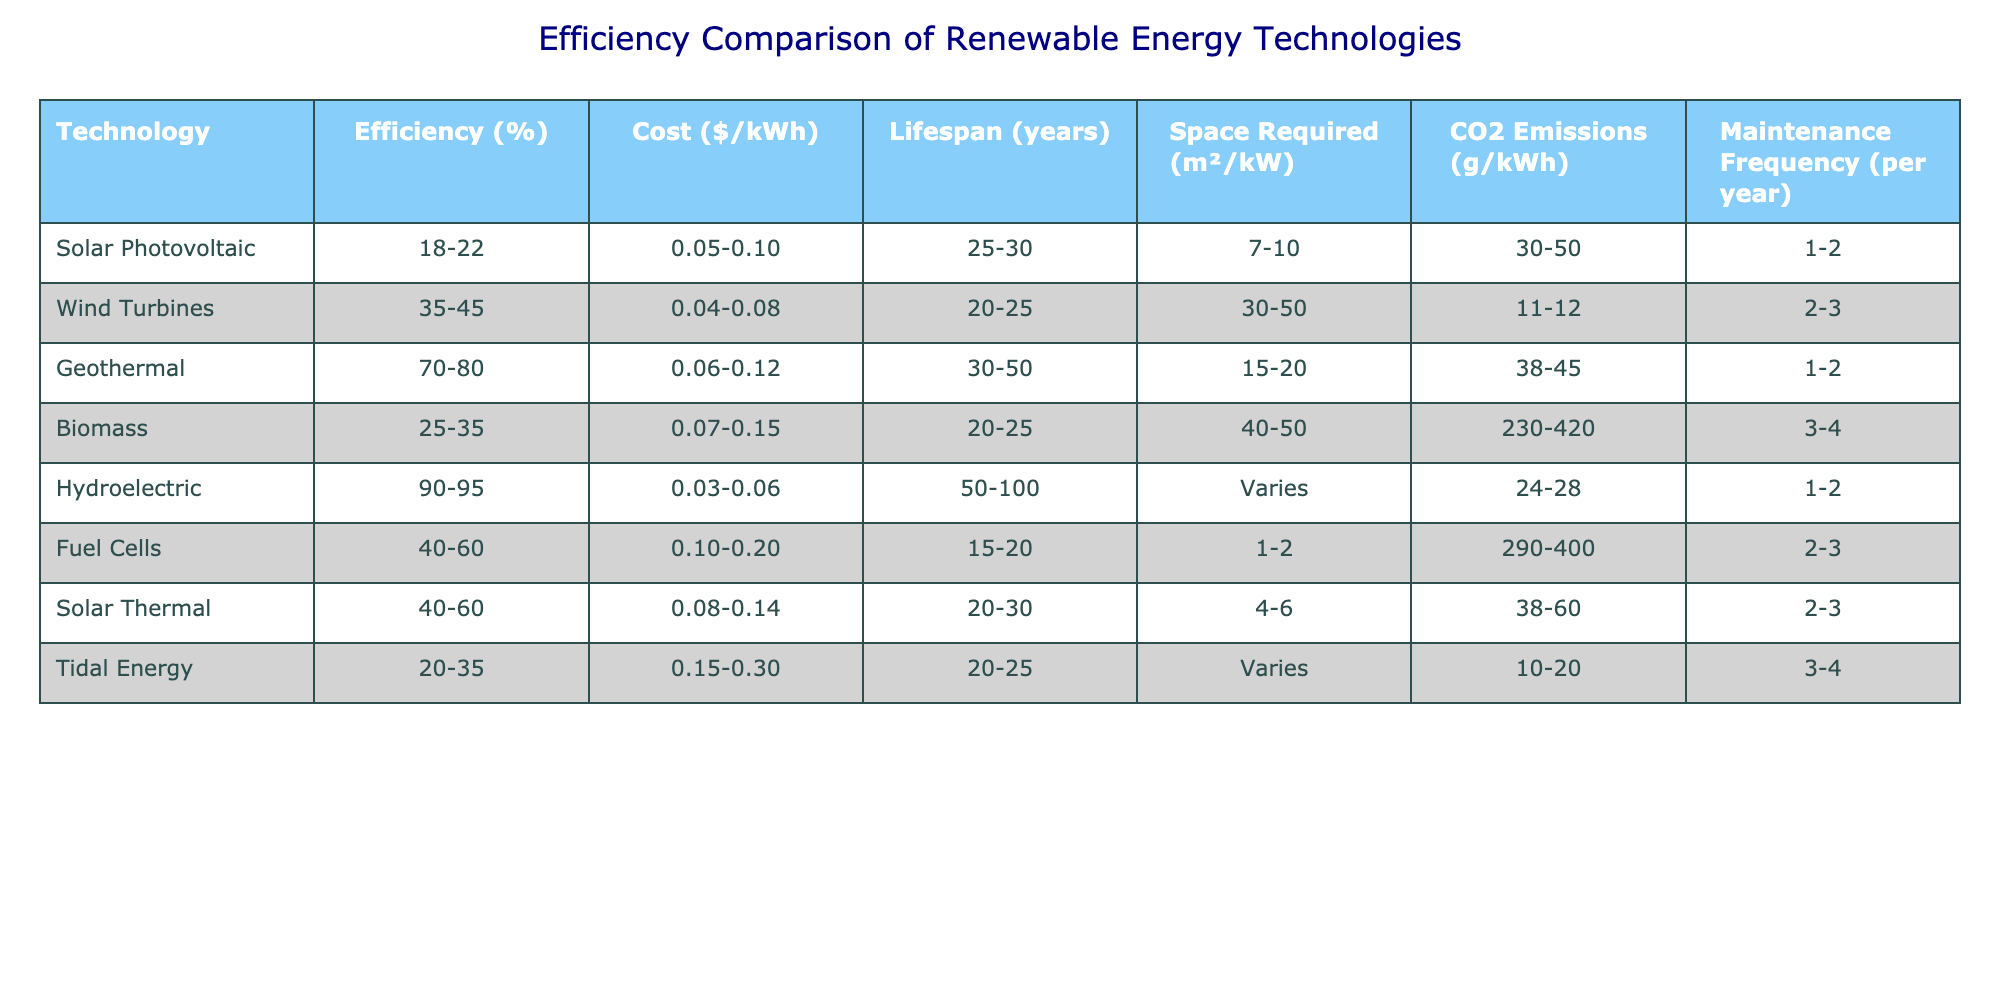What is the efficiency range of Wind Turbines? The table states that Wind Turbines have an efficiency range of 35-45%.
Answer: 35-45% Which technology has the lowest CO2 emissions? By evaluating the CO2 emissions data, Hydroelectric has the lowest emissions at 24-28 g/kWh compared to the others.
Answer: Hydroelectric What is the average lifespan of Solar Thermal and Fuel Cells? The lifespan of Solar Thermal is between 20-30 years, and Fuel Cells is between 15-20 years. Adding the midpoints (25 and 17.5) gives 42.5 years, then dividing by 2 gives an average lifespan of 21.25 years.
Answer: 21.25 years Is it true that Biomass has a higher maintenance frequency than Wind Turbines? The table shows Biomass has a maintenance frequency of 3-4 times per year, while Wind Turbines have 2-3. Therefore, it is true.
Answer: Yes Which technology is the most efficient and requires the least space? Hydroelectric is the most efficient at 90-95%, and has variable space requirements; the lowest space requirement in the table is for Fuel Cells, which needs 1-2 m²/kW. This means Hydroelectric is the top in efficiency but not in space.
Answer: Most efficient: Hydroelectric; Least space: Fuel Cells What are the differences in costs between the cheapest and most expensive technologies per kWh? The cheapest technology is Hydroelectric at $0.03-0.06 per kWh, and the most expensive is Fuel Cells at $0.10-0.20 per kWh. The difference in cost ranges from $0.10 to $0.14 depending on the price points.
Answer: $0.10 to $0.14 How does the average efficiency of solar technologies compare to that of geothermal technologies? Solar Photovoltaic has an efficiency of 18-22%, while Solar Thermal ranges from 40-60%. Taking midpoints gives an average of 20% for Solar and 55% for Geothermal. Thus, averaging the two solar technologies (20% and 55%) shows that geothermal technologies have a higher average.
Answer: Geothermal has a higher average efficiency What is the maintenance frequency difference between Biomass and Solar Photovoltaic? Biomass requires maintenance 3-4 times per year, while Solar Photovoltaic requires 1-2 times per year. The difference will be at least one occasion, hence Biomass has a higher frequency.
Answer: 1-2 times more 